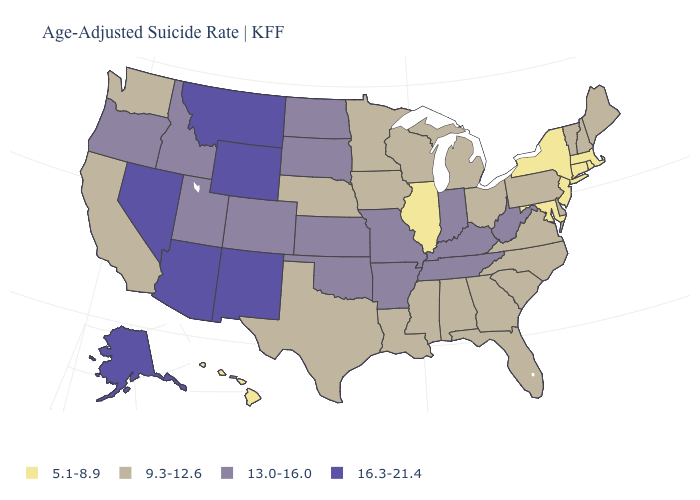Name the states that have a value in the range 9.3-12.6?
Be succinct. Alabama, California, Delaware, Florida, Georgia, Iowa, Louisiana, Maine, Michigan, Minnesota, Mississippi, Nebraska, New Hampshire, North Carolina, Ohio, Pennsylvania, South Carolina, Texas, Vermont, Virginia, Washington, Wisconsin. What is the value of Colorado?
Be succinct. 13.0-16.0. Does the map have missing data?
Quick response, please. No. What is the highest value in the USA?
Short answer required. 16.3-21.4. Does California have a lower value than Arizona?
Quick response, please. Yes. Name the states that have a value in the range 13.0-16.0?
Be succinct. Arkansas, Colorado, Idaho, Indiana, Kansas, Kentucky, Missouri, North Dakota, Oklahoma, Oregon, South Dakota, Tennessee, Utah, West Virginia. What is the value of Michigan?
Quick response, please. 9.3-12.6. How many symbols are there in the legend?
Concise answer only. 4. What is the value of Mississippi?
Concise answer only. 9.3-12.6. Does Idaho have the same value as Utah?
Answer briefly. Yes. Does Iowa have the same value as South Carolina?
Concise answer only. Yes. Name the states that have a value in the range 16.3-21.4?
Keep it brief. Alaska, Arizona, Montana, Nevada, New Mexico, Wyoming. What is the value of New York?
Answer briefly. 5.1-8.9. Among the states that border Alabama , which have the lowest value?
Quick response, please. Florida, Georgia, Mississippi. What is the value of South Dakota?
Quick response, please. 13.0-16.0. 